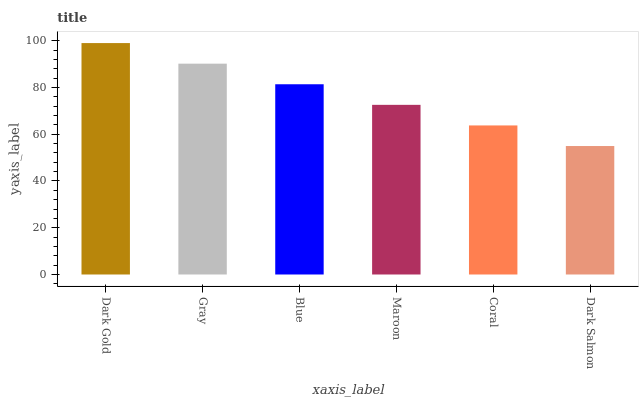Is Dark Salmon the minimum?
Answer yes or no. Yes. Is Dark Gold the maximum?
Answer yes or no. Yes. Is Gray the minimum?
Answer yes or no. No. Is Gray the maximum?
Answer yes or no. No. Is Dark Gold greater than Gray?
Answer yes or no. Yes. Is Gray less than Dark Gold?
Answer yes or no. Yes. Is Gray greater than Dark Gold?
Answer yes or no. No. Is Dark Gold less than Gray?
Answer yes or no. No. Is Blue the high median?
Answer yes or no. Yes. Is Maroon the low median?
Answer yes or no. Yes. Is Coral the high median?
Answer yes or no. No. Is Dark Salmon the low median?
Answer yes or no. No. 